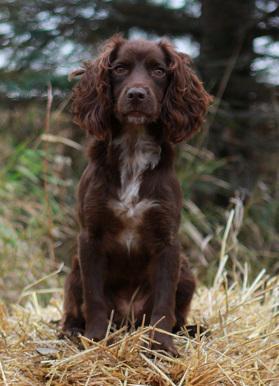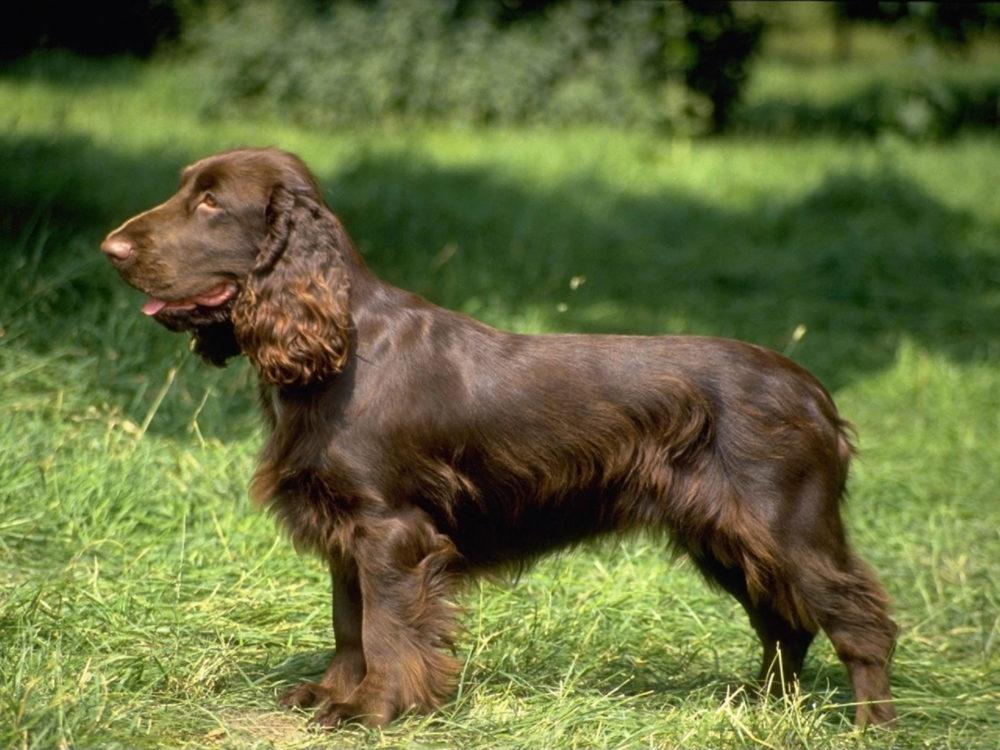The first image is the image on the left, the second image is the image on the right. Examine the images to the left and right. Is the description "The combined images include a left-facing spaniel with something large held in its mouth, and a trio of three dogs sitting together in the grass." accurate? Answer yes or no. No. 